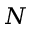Convert formula to latex. <formula><loc_0><loc_0><loc_500><loc_500>N</formula> 